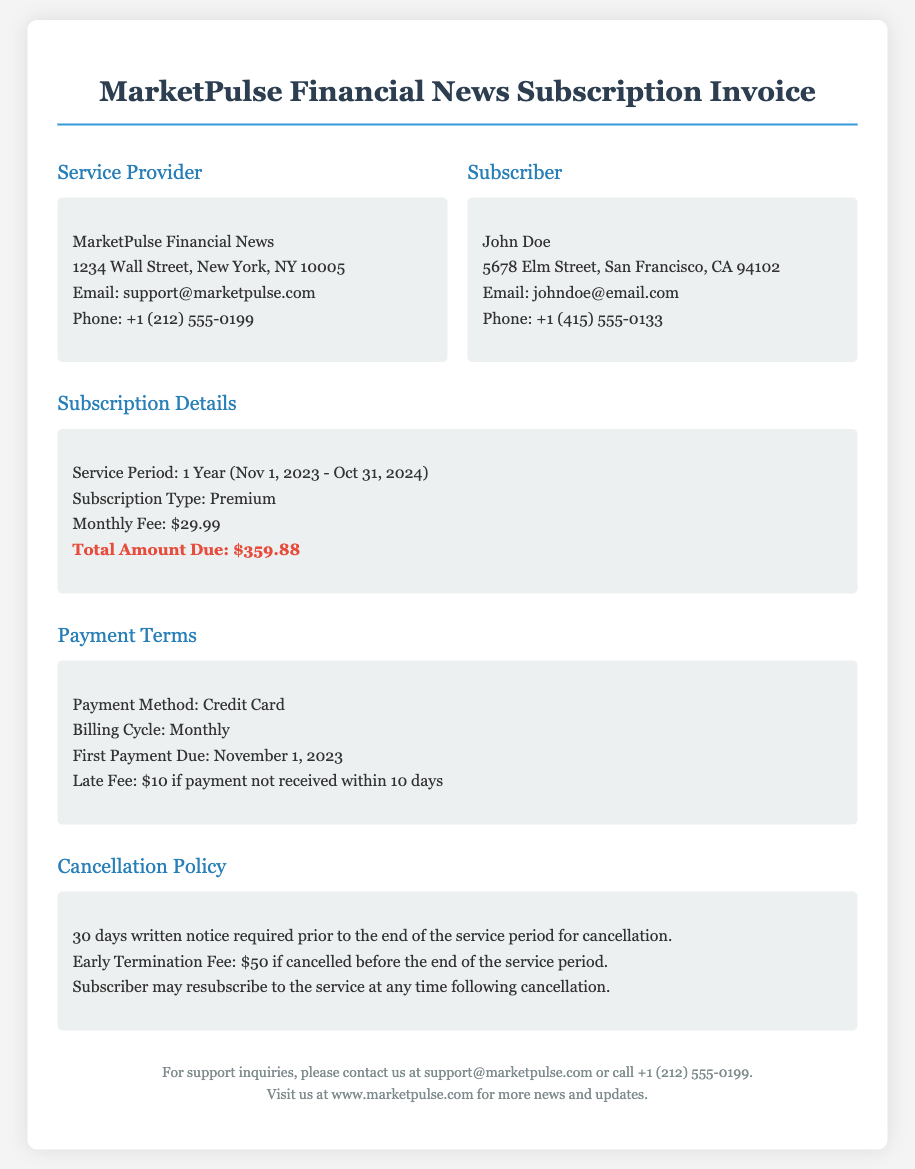What is the service period for the subscription? The service period is clearly stated in the document as lasting from November 1, 2023, to October 31, 2024.
Answer: 1 Year (Nov 1, 2023 - Oct 31, 2024) What is the total amount due for the subscription? The document specifies the total amount due for the subscription, calculated based on the monthly fee and the service period.
Answer: $359.88 What is the monthly fee for the subscription? The document outlines the monthly fee, which is specified under the Subscription Details section.
Answer: $29.99 What is required for cancellation? The document indicates that a written notice is a requirement for cancellation, emphasizing the need for advance notification.
Answer: 30 days written notice Is there a fee for early termination? The document notes an early termination fee if the subscription is cancelled before the service period ends.
Answer: $50 When is the first payment due? The first payment date is mentioned in the Payment Terms section of the document, indicating when payment should be made.
Answer: November 1, 2023 What happens if a payment is late? The document specifies a consequence for late payment, detailing what the subscriber will incur if payment is not received on time.
Answer: Late Fee: $10 if payment not received within 10 days Can the subscriber resubscribe after cancellation? The document clarifies the possibility of resubscribing, indicating that this option is available following cancellation.
Answer: Yes 